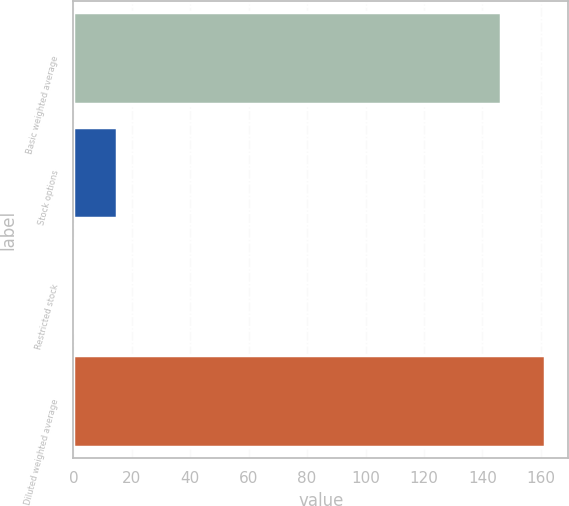Convert chart. <chart><loc_0><loc_0><loc_500><loc_500><bar_chart><fcel>Basic weighted average<fcel>Stock options<fcel>Restricted stock<fcel>Diluted weighted average<nl><fcel>146.5<fcel>14.91<fcel>0.1<fcel>161.31<nl></chart> 